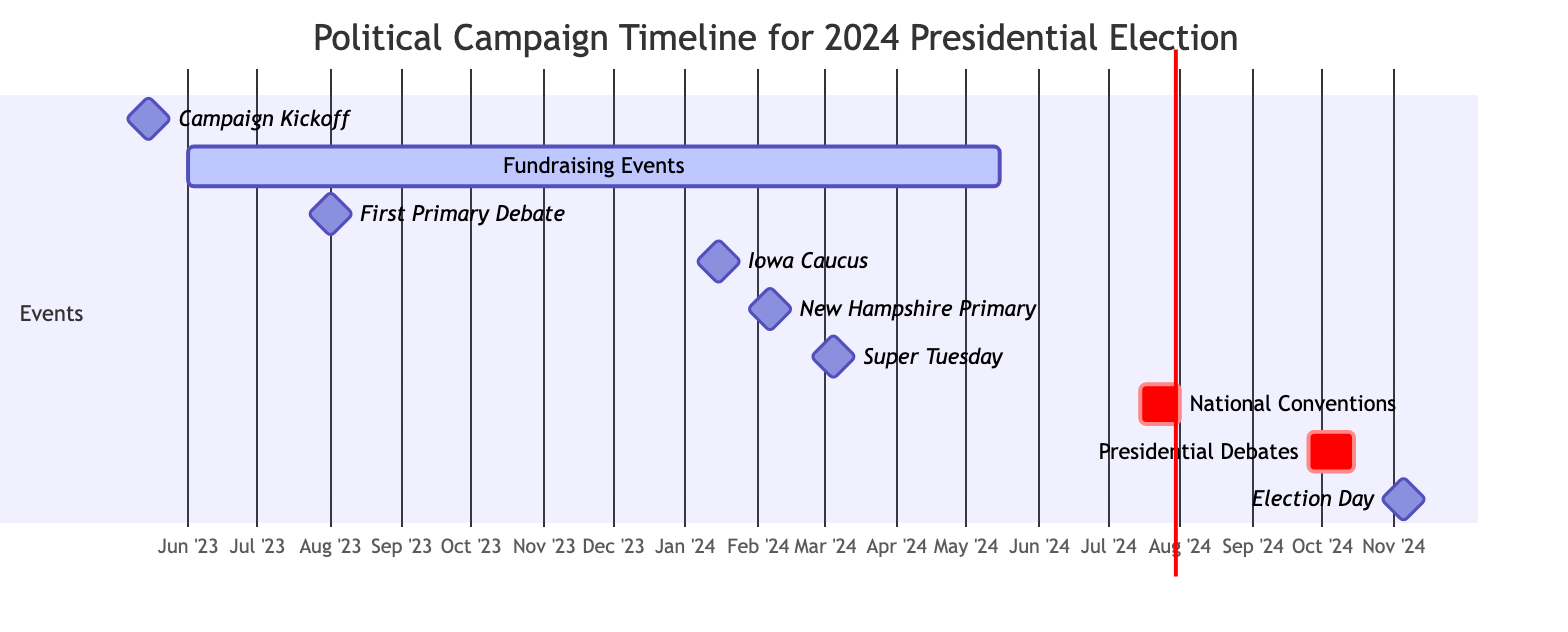What is the date of the Campaign Kickoff? The Campaign Kickoff is marked on the diagram with a specific date, which is noted to be May 15, 2023, as indicated in the description and timeline.
Answer: May 15, 2023 How long do the Fundraising Events last? The duration of the Fundraising Events can be determined by looking at the start and end dates on the diagram. It begins on June 1, 2023, and ends on May 15, 2024, which gives a total duration of nearly 12 months.
Answer: 11 months What is the first milestone listed in the Gantt chart? The first milestone shown in the Gantt chart is the Campaign Kickoff, which occurs on May 15, 2023. This is the starting point of the timeline for the 2024 Presidential Election campaign.
Answer: Campaign Kickoff How many debates are scheduled before Election Day? By examining the diagram, we can count the scheduled debates: there is one First Primary Debate and three Presidential Debates, totaling four debates before Election Day on November 5, 2024.
Answer: 4 Which event occurs between the Iowa Caucus and the New Hampshire Primary? Looking at the timeline, the Iowa Caucus occurs on January 15, 2024, and the New Hampshire Primary is on February 6, 2024. There are no specific events listed in between these dates, which indicates that there are likely no scheduled key events.
Answer: None What is the significance of Super Tuesday in this timeline? Super Tuesday is identified as a critical milestone in the diagram and is scheduled for March 5, 2024. This day is significant because multiple states simultaneously hold their primaries, which can greatly impact the campaign's direction.
Answer: Critical milestone What date do the National Conventions start? The National Conventions begin on July 15, 2024. This date is clearly marked in the Gantt chart, indicating the starting point of these important political gatherings.
Answer: July 15, 2024 How many major fundraising events take place throughout this timeline? The diagram specifies that Fundraising Events take place continuously from June 1, 2023, to May 15, 2024. Since it is an ongoing event, numerous fundraising activities will occur, though the exact number is not defined by the chart itself.
Answer: Ongoing When do the Presidential Debates take place? The Presidential Debates are scheduled between September 25, 2024, and October 15, 2024, as depicted in the timeline, indicating this crucial phase of the campaign.
Answer: September 25 to October 15, 2024 